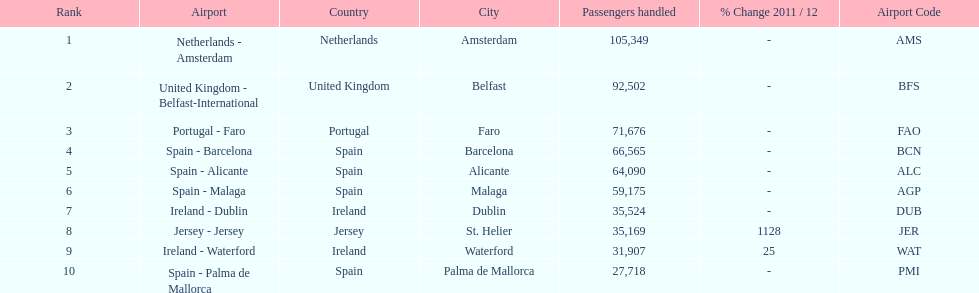How many passengers were handled in an airport in spain? 217,548. 